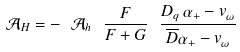<formula> <loc_0><loc_0><loc_500><loc_500>\mathcal { A } _ { H } = - \ \mathcal { A } _ { h } \ \frac { F } { F + G } \ \frac { D _ { q } \, \alpha _ { + } - v _ { \omega } } { \overline { D } \alpha _ { + } - v _ { \omega } }</formula> 